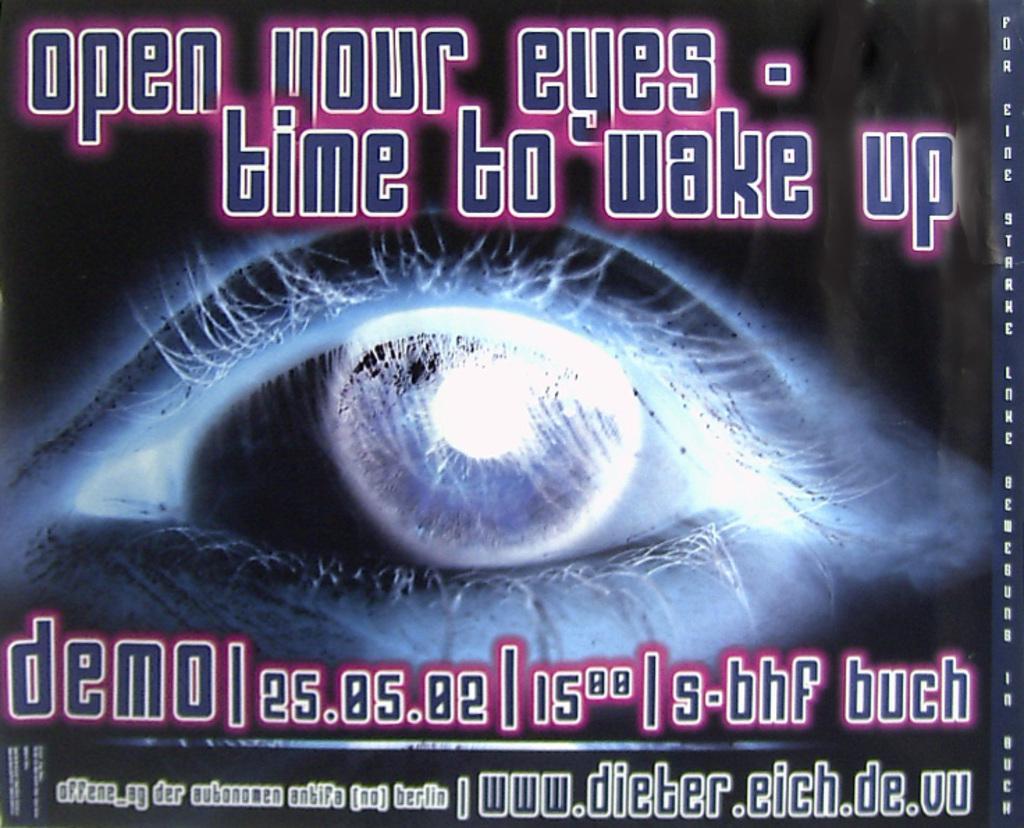Describe this image in one or two sentences. In this image we can see an eye, here is the pupil, there is the matter written on it. 